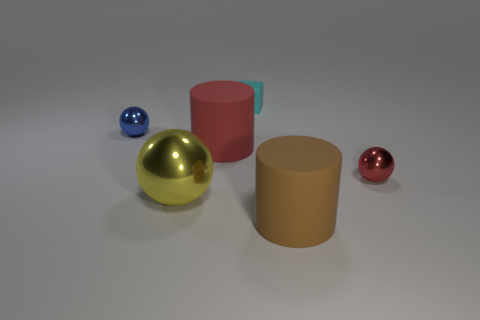What number of things are small things in front of the blue thing or matte things in front of the small red object?
Make the answer very short. 2. There is a large thing that is both in front of the small red thing and left of the tiny block; what is its color?
Provide a short and direct response. Yellow. Is the number of small red things greater than the number of tiny red shiny cylinders?
Provide a short and direct response. Yes. There is a shiny object behind the small red object; is it the same shape as the small cyan matte object?
Offer a terse response. No. What number of rubber things are either cyan spheres or cyan blocks?
Your answer should be very brief. 1. Is there a blue ball made of the same material as the red sphere?
Make the answer very short. Yes. What material is the tiny blue object?
Provide a succinct answer. Metal. The tiny metallic thing that is in front of the small shiny sphere left of the small thing behind the tiny blue thing is what shape?
Keep it short and to the point. Sphere. Is the number of large brown rubber cylinders to the right of the cube greater than the number of purple metal spheres?
Provide a short and direct response. Yes. Do the tiny blue thing and the big matte object that is in front of the large red matte thing have the same shape?
Offer a very short reply. No. 